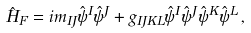<formula> <loc_0><loc_0><loc_500><loc_500>\hat { H } _ { F } = i m _ { I J } \hat { \psi } ^ { I } \hat { \psi } ^ { J } + g _ { I J K L } \hat { \psi } ^ { I } \hat { \psi } ^ { J } \hat { \psi } ^ { K } \hat { \psi } ^ { L } \, ,</formula> 